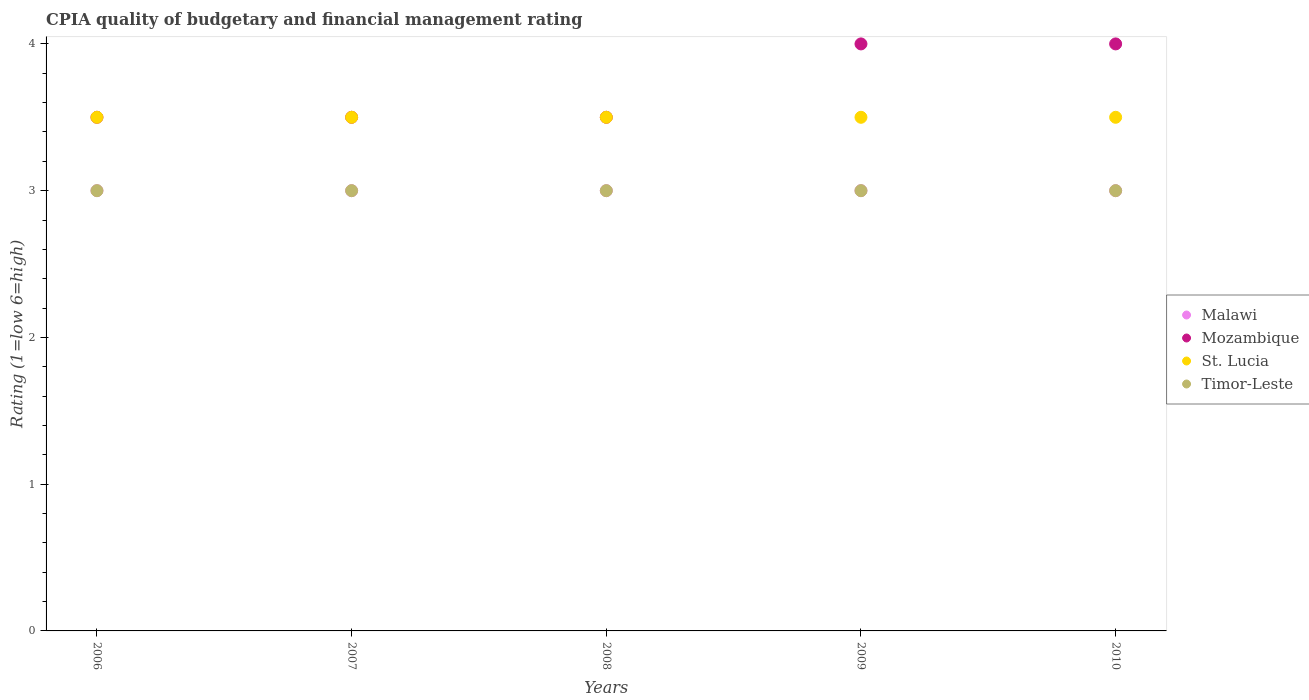How many different coloured dotlines are there?
Provide a succinct answer. 4. What is the CPIA rating in St. Lucia in 2010?
Provide a succinct answer. 3.5. In which year was the CPIA rating in Timor-Leste maximum?
Keep it short and to the point. 2006. In which year was the CPIA rating in Malawi minimum?
Your answer should be compact. 2006. What is the difference between the CPIA rating in St. Lucia in 2007 and that in 2010?
Make the answer very short. 0. What is the difference between the CPIA rating in St. Lucia in 2010 and the CPIA rating in Malawi in 2009?
Provide a succinct answer. 0.5. What is the average CPIA rating in Mozambique per year?
Your response must be concise. 3.7. What is the ratio of the CPIA rating in St. Lucia in 2006 to that in 2007?
Keep it short and to the point. 1. Is the CPIA rating in Timor-Leste in 2007 less than that in 2010?
Your response must be concise. No. What is the difference between the highest and the lowest CPIA rating in Timor-Leste?
Provide a succinct answer. 0. Is the sum of the CPIA rating in Malawi in 2007 and 2008 greater than the maximum CPIA rating in St. Lucia across all years?
Your response must be concise. Yes. Is it the case that in every year, the sum of the CPIA rating in St. Lucia and CPIA rating in Timor-Leste  is greater than the sum of CPIA rating in Malawi and CPIA rating in Mozambique?
Make the answer very short. Yes. Is it the case that in every year, the sum of the CPIA rating in Timor-Leste and CPIA rating in Mozambique  is greater than the CPIA rating in St. Lucia?
Keep it short and to the point. Yes. Is the CPIA rating in Timor-Leste strictly less than the CPIA rating in Malawi over the years?
Your answer should be very brief. No. How many years are there in the graph?
Your response must be concise. 5. What is the difference between two consecutive major ticks on the Y-axis?
Give a very brief answer. 1. Where does the legend appear in the graph?
Your answer should be very brief. Center right. What is the title of the graph?
Make the answer very short. CPIA quality of budgetary and financial management rating. Does "Vietnam" appear as one of the legend labels in the graph?
Ensure brevity in your answer.  No. What is the label or title of the X-axis?
Offer a very short reply. Years. What is the Rating (1=low 6=high) of Malawi in 2006?
Give a very brief answer. 3. What is the Rating (1=low 6=high) of Mozambique in 2006?
Keep it short and to the point. 3.5. What is the Rating (1=low 6=high) of Timor-Leste in 2006?
Your answer should be very brief. 3. What is the Rating (1=low 6=high) in Malawi in 2007?
Offer a very short reply. 3. What is the Rating (1=low 6=high) in Mozambique in 2007?
Your answer should be very brief. 3.5. What is the Rating (1=low 6=high) of Mozambique in 2008?
Keep it short and to the point. 3.5. What is the Rating (1=low 6=high) in St. Lucia in 2008?
Keep it short and to the point. 3.5. What is the Rating (1=low 6=high) in Malawi in 2009?
Give a very brief answer. 3. What is the Rating (1=low 6=high) in Malawi in 2010?
Offer a very short reply. 3. What is the Rating (1=low 6=high) in Mozambique in 2010?
Make the answer very short. 4. Across all years, what is the maximum Rating (1=low 6=high) of Malawi?
Your answer should be very brief. 3. Across all years, what is the minimum Rating (1=low 6=high) in Malawi?
Offer a very short reply. 3. Across all years, what is the minimum Rating (1=low 6=high) of St. Lucia?
Give a very brief answer. 3.5. What is the total Rating (1=low 6=high) in St. Lucia in the graph?
Keep it short and to the point. 17.5. What is the difference between the Rating (1=low 6=high) in Mozambique in 2006 and that in 2007?
Your response must be concise. 0. What is the difference between the Rating (1=low 6=high) of St. Lucia in 2006 and that in 2007?
Offer a very short reply. 0. What is the difference between the Rating (1=low 6=high) of Timor-Leste in 2006 and that in 2008?
Provide a short and direct response. 0. What is the difference between the Rating (1=low 6=high) of Malawi in 2006 and that in 2009?
Keep it short and to the point. 0. What is the difference between the Rating (1=low 6=high) in Mozambique in 2006 and that in 2009?
Your response must be concise. -0.5. What is the difference between the Rating (1=low 6=high) of St. Lucia in 2006 and that in 2009?
Provide a short and direct response. 0. What is the difference between the Rating (1=low 6=high) in Timor-Leste in 2006 and that in 2009?
Make the answer very short. 0. What is the difference between the Rating (1=low 6=high) of Timor-Leste in 2006 and that in 2010?
Give a very brief answer. 0. What is the difference between the Rating (1=low 6=high) of Timor-Leste in 2007 and that in 2008?
Offer a terse response. 0. What is the difference between the Rating (1=low 6=high) of Mozambique in 2007 and that in 2010?
Offer a terse response. -0.5. What is the difference between the Rating (1=low 6=high) in St. Lucia in 2007 and that in 2010?
Make the answer very short. 0. What is the difference between the Rating (1=low 6=high) in Malawi in 2008 and that in 2009?
Provide a short and direct response. 0. What is the difference between the Rating (1=low 6=high) in St. Lucia in 2008 and that in 2009?
Offer a terse response. 0. What is the difference between the Rating (1=low 6=high) in Timor-Leste in 2008 and that in 2009?
Provide a short and direct response. 0. What is the difference between the Rating (1=low 6=high) of Malawi in 2008 and that in 2010?
Your response must be concise. 0. What is the difference between the Rating (1=low 6=high) of Mozambique in 2008 and that in 2010?
Make the answer very short. -0.5. What is the difference between the Rating (1=low 6=high) of St. Lucia in 2008 and that in 2010?
Give a very brief answer. 0. What is the difference between the Rating (1=low 6=high) of Malawi in 2009 and that in 2010?
Your response must be concise. 0. What is the difference between the Rating (1=low 6=high) in St. Lucia in 2009 and that in 2010?
Offer a very short reply. 0. What is the difference between the Rating (1=low 6=high) of Malawi in 2006 and the Rating (1=low 6=high) of Mozambique in 2007?
Keep it short and to the point. -0.5. What is the difference between the Rating (1=low 6=high) in Malawi in 2006 and the Rating (1=low 6=high) in Timor-Leste in 2007?
Provide a short and direct response. 0. What is the difference between the Rating (1=low 6=high) in Mozambique in 2006 and the Rating (1=low 6=high) in Timor-Leste in 2007?
Ensure brevity in your answer.  0.5. What is the difference between the Rating (1=low 6=high) in Malawi in 2006 and the Rating (1=low 6=high) in Mozambique in 2008?
Make the answer very short. -0.5. What is the difference between the Rating (1=low 6=high) in Mozambique in 2006 and the Rating (1=low 6=high) in St. Lucia in 2008?
Offer a terse response. 0. What is the difference between the Rating (1=low 6=high) of St. Lucia in 2006 and the Rating (1=low 6=high) of Timor-Leste in 2008?
Make the answer very short. 0.5. What is the difference between the Rating (1=low 6=high) in Mozambique in 2006 and the Rating (1=low 6=high) in St. Lucia in 2009?
Ensure brevity in your answer.  0. What is the difference between the Rating (1=low 6=high) in Mozambique in 2006 and the Rating (1=low 6=high) in Timor-Leste in 2009?
Ensure brevity in your answer.  0.5. What is the difference between the Rating (1=low 6=high) in St. Lucia in 2006 and the Rating (1=low 6=high) in Timor-Leste in 2009?
Your answer should be very brief. 0.5. What is the difference between the Rating (1=low 6=high) in Malawi in 2006 and the Rating (1=low 6=high) in Mozambique in 2010?
Ensure brevity in your answer.  -1. What is the difference between the Rating (1=low 6=high) of Malawi in 2006 and the Rating (1=low 6=high) of St. Lucia in 2010?
Provide a succinct answer. -0.5. What is the difference between the Rating (1=low 6=high) in Malawi in 2006 and the Rating (1=low 6=high) in Timor-Leste in 2010?
Provide a succinct answer. 0. What is the difference between the Rating (1=low 6=high) of Malawi in 2007 and the Rating (1=low 6=high) of Mozambique in 2008?
Keep it short and to the point. -0.5. What is the difference between the Rating (1=low 6=high) of Malawi in 2007 and the Rating (1=low 6=high) of St. Lucia in 2008?
Your response must be concise. -0.5. What is the difference between the Rating (1=low 6=high) of Malawi in 2007 and the Rating (1=low 6=high) of Timor-Leste in 2008?
Your answer should be very brief. 0. What is the difference between the Rating (1=low 6=high) in Mozambique in 2007 and the Rating (1=low 6=high) in Timor-Leste in 2008?
Your response must be concise. 0.5. What is the difference between the Rating (1=low 6=high) in St. Lucia in 2007 and the Rating (1=low 6=high) in Timor-Leste in 2008?
Ensure brevity in your answer.  0.5. What is the difference between the Rating (1=low 6=high) in Malawi in 2007 and the Rating (1=low 6=high) in Mozambique in 2009?
Offer a terse response. -1. What is the difference between the Rating (1=low 6=high) in Malawi in 2007 and the Rating (1=low 6=high) in Timor-Leste in 2009?
Keep it short and to the point. 0. What is the difference between the Rating (1=low 6=high) of St. Lucia in 2007 and the Rating (1=low 6=high) of Timor-Leste in 2009?
Provide a short and direct response. 0.5. What is the difference between the Rating (1=low 6=high) of Malawi in 2007 and the Rating (1=low 6=high) of Timor-Leste in 2010?
Ensure brevity in your answer.  0. What is the difference between the Rating (1=low 6=high) in Mozambique in 2007 and the Rating (1=low 6=high) in St. Lucia in 2010?
Provide a short and direct response. 0. What is the difference between the Rating (1=low 6=high) of St. Lucia in 2007 and the Rating (1=low 6=high) of Timor-Leste in 2010?
Offer a terse response. 0.5. What is the difference between the Rating (1=low 6=high) of Malawi in 2008 and the Rating (1=low 6=high) of St. Lucia in 2009?
Give a very brief answer. -0.5. What is the difference between the Rating (1=low 6=high) of Malawi in 2008 and the Rating (1=low 6=high) of Timor-Leste in 2009?
Ensure brevity in your answer.  0. What is the difference between the Rating (1=low 6=high) in Mozambique in 2008 and the Rating (1=low 6=high) in St. Lucia in 2009?
Keep it short and to the point. 0. What is the difference between the Rating (1=low 6=high) in Malawi in 2008 and the Rating (1=low 6=high) in Mozambique in 2010?
Provide a succinct answer. -1. What is the difference between the Rating (1=low 6=high) of Malawi in 2008 and the Rating (1=low 6=high) of St. Lucia in 2010?
Offer a terse response. -0.5. What is the difference between the Rating (1=low 6=high) in Malawi in 2008 and the Rating (1=low 6=high) in Timor-Leste in 2010?
Provide a short and direct response. 0. What is the difference between the Rating (1=low 6=high) of Mozambique in 2008 and the Rating (1=low 6=high) of Timor-Leste in 2010?
Offer a terse response. 0.5. What is the difference between the Rating (1=low 6=high) in Malawi in 2009 and the Rating (1=low 6=high) in St. Lucia in 2010?
Give a very brief answer. -0.5. What is the difference between the Rating (1=low 6=high) in Malawi in 2009 and the Rating (1=low 6=high) in Timor-Leste in 2010?
Make the answer very short. 0. What is the difference between the Rating (1=low 6=high) of Mozambique in 2009 and the Rating (1=low 6=high) of St. Lucia in 2010?
Offer a terse response. 0.5. What is the difference between the Rating (1=low 6=high) in Mozambique in 2009 and the Rating (1=low 6=high) in Timor-Leste in 2010?
Your answer should be compact. 1. What is the average Rating (1=low 6=high) of St. Lucia per year?
Offer a terse response. 3.5. What is the average Rating (1=low 6=high) in Timor-Leste per year?
Provide a short and direct response. 3. In the year 2006, what is the difference between the Rating (1=low 6=high) of Malawi and Rating (1=low 6=high) of Mozambique?
Give a very brief answer. -0.5. In the year 2006, what is the difference between the Rating (1=low 6=high) of Malawi and Rating (1=low 6=high) of St. Lucia?
Your answer should be very brief. -0.5. In the year 2006, what is the difference between the Rating (1=low 6=high) in Mozambique and Rating (1=low 6=high) in St. Lucia?
Offer a very short reply. 0. In the year 2006, what is the difference between the Rating (1=low 6=high) of Mozambique and Rating (1=low 6=high) of Timor-Leste?
Give a very brief answer. 0.5. In the year 2006, what is the difference between the Rating (1=low 6=high) of St. Lucia and Rating (1=low 6=high) of Timor-Leste?
Make the answer very short. 0.5. In the year 2007, what is the difference between the Rating (1=low 6=high) in Malawi and Rating (1=low 6=high) in Mozambique?
Give a very brief answer. -0.5. In the year 2007, what is the difference between the Rating (1=low 6=high) of Malawi and Rating (1=low 6=high) of St. Lucia?
Your answer should be compact. -0.5. In the year 2007, what is the difference between the Rating (1=low 6=high) in Malawi and Rating (1=low 6=high) in Timor-Leste?
Make the answer very short. 0. In the year 2007, what is the difference between the Rating (1=low 6=high) of Mozambique and Rating (1=low 6=high) of St. Lucia?
Ensure brevity in your answer.  0. In the year 2007, what is the difference between the Rating (1=low 6=high) of Mozambique and Rating (1=low 6=high) of Timor-Leste?
Offer a terse response. 0.5. In the year 2007, what is the difference between the Rating (1=low 6=high) of St. Lucia and Rating (1=low 6=high) of Timor-Leste?
Make the answer very short. 0.5. In the year 2008, what is the difference between the Rating (1=low 6=high) of Malawi and Rating (1=low 6=high) of Mozambique?
Your response must be concise. -0.5. In the year 2008, what is the difference between the Rating (1=low 6=high) in Malawi and Rating (1=low 6=high) in Timor-Leste?
Make the answer very short. 0. In the year 2008, what is the difference between the Rating (1=low 6=high) in Mozambique and Rating (1=low 6=high) in St. Lucia?
Give a very brief answer. 0. In the year 2008, what is the difference between the Rating (1=low 6=high) of St. Lucia and Rating (1=low 6=high) of Timor-Leste?
Provide a short and direct response. 0.5. In the year 2009, what is the difference between the Rating (1=low 6=high) in Mozambique and Rating (1=low 6=high) in St. Lucia?
Ensure brevity in your answer.  0.5. In the year 2010, what is the difference between the Rating (1=low 6=high) in Malawi and Rating (1=low 6=high) in Mozambique?
Offer a terse response. -1. In the year 2010, what is the difference between the Rating (1=low 6=high) in Malawi and Rating (1=low 6=high) in St. Lucia?
Keep it short and to the point. -0.5. In the year 2010, what is the difference between the Rating (1=low 6=high) in Malawi and Rating (1=low 6=high) in Timor-Leste?
Your answer should be very brief. 0. In the year 2010, what is the difference between the Rating (1=low 6=high) in Mozambique and Rating (1=low 6=high) in St. Lucia?
Your response must be concise. 0.5. What is the ratio of the Rating (1=low 6=high) in Malawi in 2006 to that in 2007?
Your answer should be compact. 1. What is the ratio of the Rating (1=low 6=high) of Timor-Leste in 2006 to that in 2007?
Offer a terse response. 1. What is the ratio of the Rating (1=low 6=high) in Malawi in 2006 to that in 2008?
Your answer should be compact. 1. What is the ratio of the Rating (1=low 6=high) in Mozambique in 2006 to that in 2008?
Offer a terse response. 1. What is the ratio of the Rating (1=low 6=high) of Malawi in 2006 to that in 2009?
Offer a terse response. 1. What is the ratio of the Rating (1=low 6=high) of Mozambique in 2006 to that in 2009?
Give a very brief answer. 0.88. What is the ratio of the Rating (1=low 6=high) in St. Lucia in 2006 to that in 2009?
Provide a short and direct response. 1. What is the ratio of the Rating (1=low 6=high) of St. Lucia in 2006 to that in 2010?
Provide a short and direct response. 1. What is the ratio of the Rating (1=low 6=high) of Timor-Leste in 2006 to that in 2010?
Offer a terse response. 1. What is the ratio of the Rating (1=low 6=high) in Malawi in 2007 to that in 2008?
Your answer should be compact. 1. What is the ratio of the Rating (1=low 6=high) of Mozambique in 2007 to that in 2008?
Provide a short and direct response. 1. What is the ratio of the Rating (1=low 6=high) of Malawi in 2007 to that in 2009?
Your answer should be compact. 1. What is the ratio of the Rating (1=low 6=high) in Mozambique in 2007 to that in 2009?
Ensure brevity in your answer.  0.88. What is the ratio of the Rating (1=low 6=high) in St. Lucia in 2007 to that in 2009?
Give a very brief answer. 1. What is the ratio of the Rating (1=low 6=high) of Mozambique in 2007 to that in 2010?
Your response must be concise. 0.88. What is the ratio of the Rating (1=low 6=high) of St. Lucia in 2007 to that in 2010?
Your answer should be compact. 1. What is the ratio of the Rating (1=low 6=high) of Timor-Leste in 2007 to that in 2010?
Offer a terse response. 1. What is the ratio of the Rating (1=low 6=high) of Malawi in 2008 to that in 2009?
Ensure brevity in your answer.  1. What is the ratio of the Rating (1=low 6=high) in Mozambique in 2008 to that in 2009?
Keep it short and to the point. 0.88. What is the ratio of the Rating (1=low 6=high) in St. Lucia in 2008 to that in 2009?
Your answer should be very brief. 1. What is the ratio of the Rating (1=low 6=high) in Malawi in 2008 to that in 2010?
Your answer should be compact. 1. What is the ratio of the Rating (1=low 6=high) in Mozambique in 2008 to that in 2010?
Provide a short and direct response. 0.88. What is the ratio of the Rating (1=low 6=high) in Timor-Leste in 2008 to that in 2010?
Make the answer very short. 1. What is the ratio of the Rating (1=low 6=high) in St. Lucia in 2009 to that in 2010?
Make the answer very short. 1. What is the ratio of the Rating (1=low 6=high) in Timor-Leste in 2009 to that in 2010?
Offer a very short reply. 1. What is the difference between the highest and the second highest Rating (1=low 6=high) of Mozambique?
Your answer should be compact. 0. What is the difference between the highest and the lowest Rating (1=low 6=high) in Malawi?
Make the answer very short. 0. What is the difference between the highest and the lowest Rating (1=low 6=high) of Mozambique?
Keep it short and to the point. 0.5. What is the difference between the highest and the lowest Rating (1=low 6=high) in St. Lucia?
Keep it short and to the point. 0. What is the difference between the highest and the lowest Rating (1=low 6=high) of Timor-Leste?
Offer a terse response. 0. 